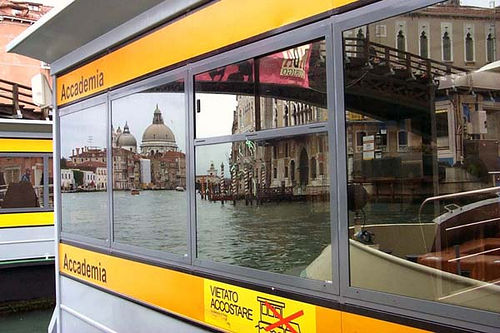What activities or events might be taking place in this location? Given the busy waterways and the presence of a boat station, this location is likely a hub of activity with locals and tourists boarding and disembarking from boats. It could also be a popular spot for sightseeing, photography, and leisurely strolls along the water's edge, capturing the essence of Venetian life. Describe a realistic, long scenario involving the people in this scene. In a bustling afternoon, the boat station 'Accademia' sees a mix of locals and tourists alighting from the boats. A group of friends, cameras in hand, discuss their next destination while pointing towards the majestic dome of Basilica di Santa Maria della Salute reflected in the station's windows. Nearby, an elderly couple sits on a bench, reminiscing about their honeymoon in Venice decades ago as they watch a young artist sketch the canal scene with quick, precise strokes. The air is filled with the sounds of boat engines, laughter, and the occasional call of a gondolier under the summer sun. Create a very creative, imaginative interaction related to this image. A portal embedded in the reflections of the boat station opens into a parallel Venice where buildings float in mid-air, connected by suspended bridges of glass. Visitors from across dimensions arrive through shimmering gondolas that sail through the sky instead of water. A team of explorers, tasked with unearthing ancient floating treasures, step through the portal and embark on a quest to discover the mysteries of this mirrored Venice, guided by an enigmatic gondolier with secrets to tell. Describe a short realistic scenario in this image. A tourist hurriedly checks his map while boarding the boat at Accademia, eager to make it in time for a guided tour of the historic city. He glances back to capture a quick photo of the stunning reflections before the boat departs. 